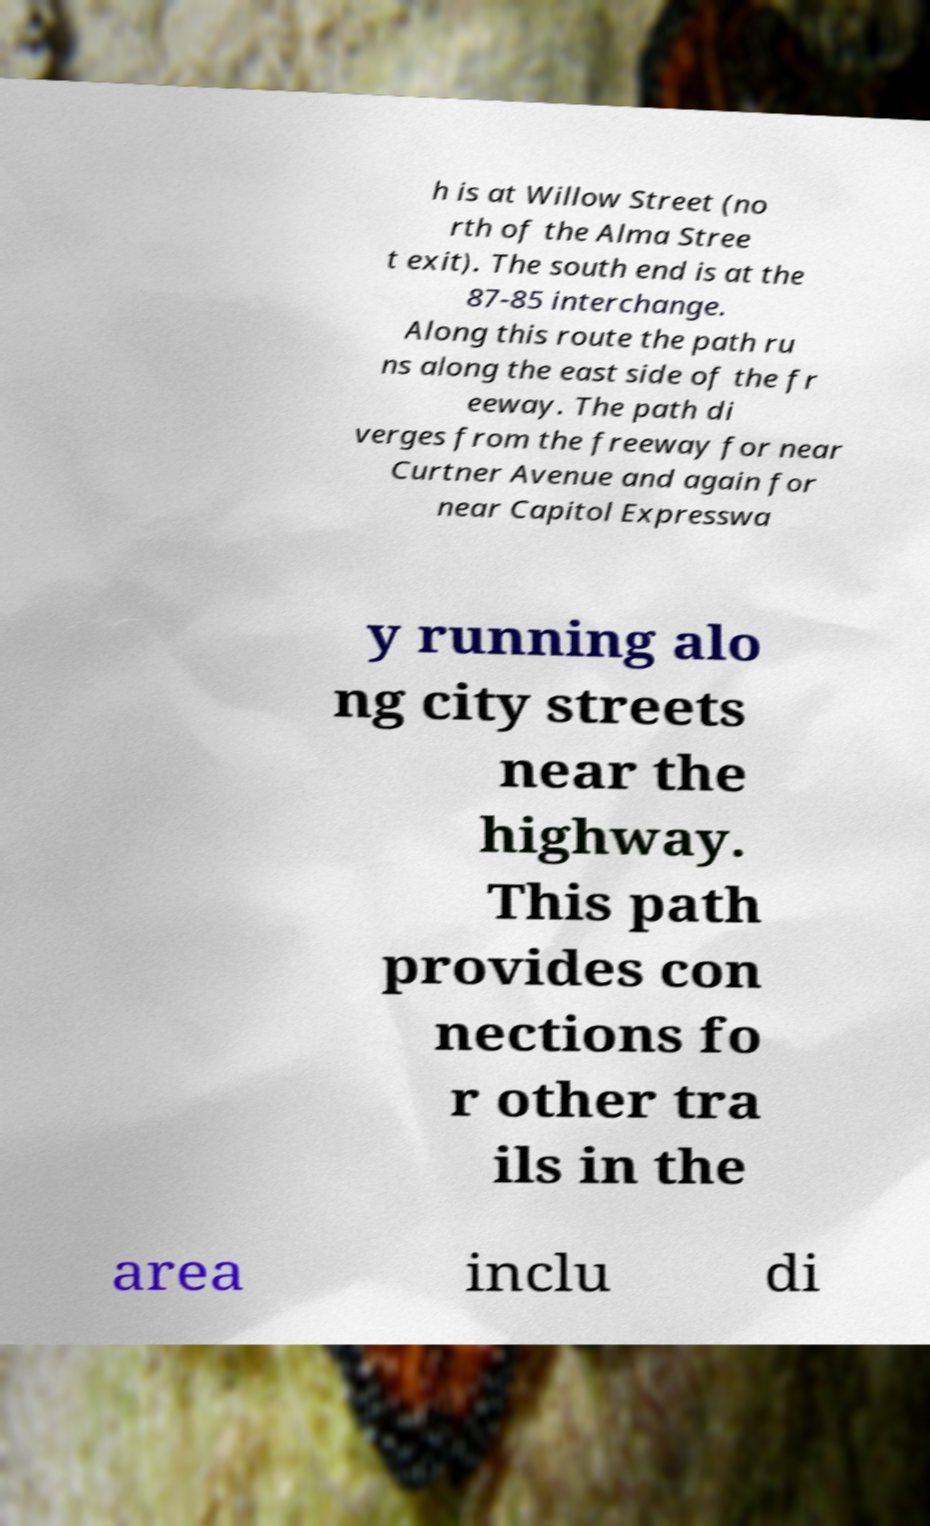Can you accurately transcribe the text from the provided image for me? h is at Willow Street (no rth of the Alma Stree t exit). The south end is at the 87-85 interchange. Along this route the path ru ns along the east side of the fr eeway. The path di verges from the freeway for near Curtner Avenue and again for near Capitol Expresswa y running alo ng city streets near the highway. This path provides con nections fo r other tra ils in the area inclu di 